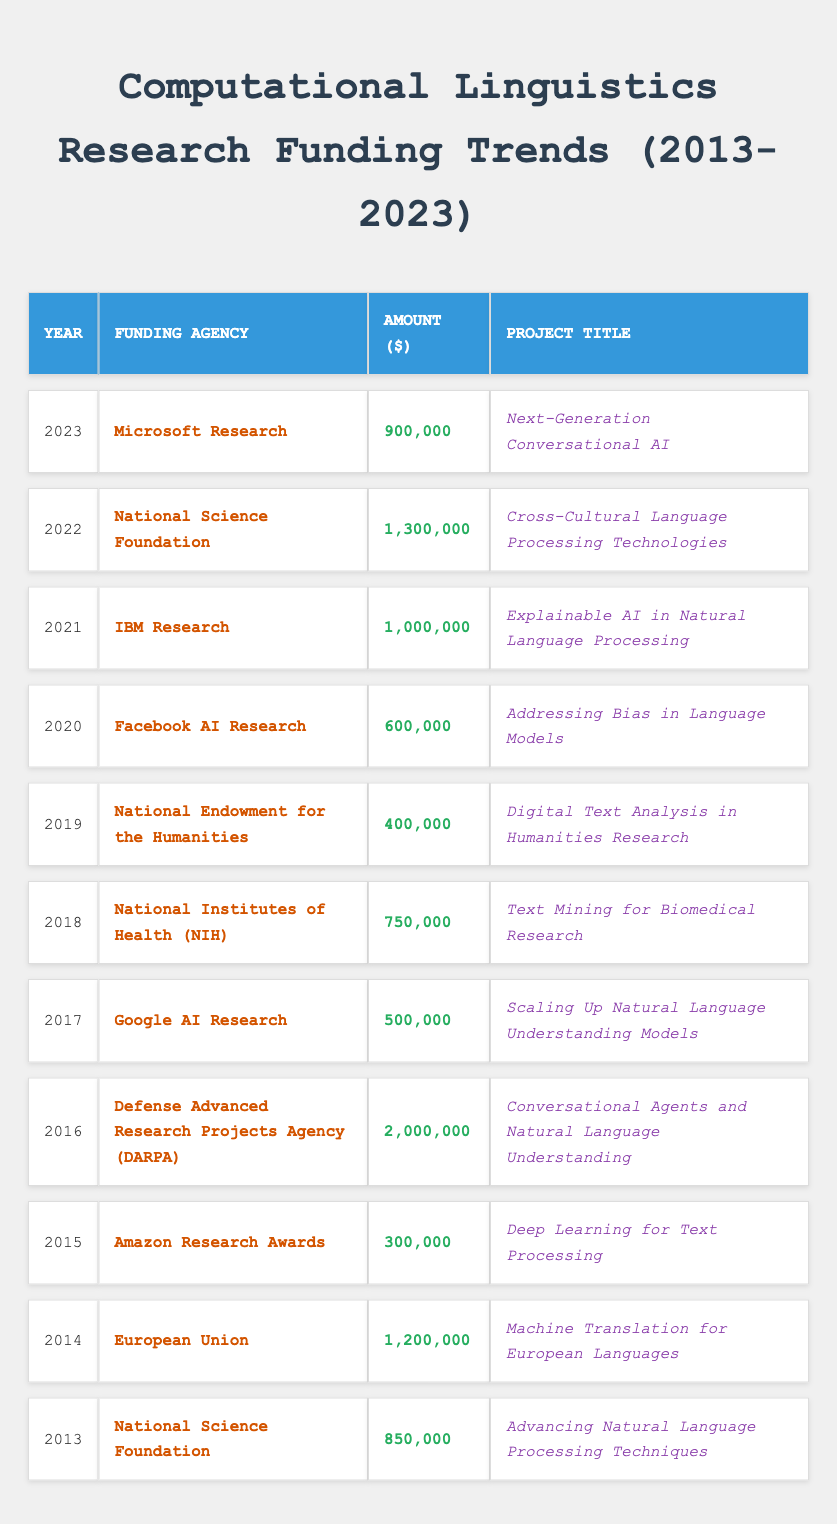What was the highest funding amount in a year? By reviewing the amounts funded each year, 2,000,000 from DARPA in 2016 is the highest.
Answer: 2,000,000 Which funding agency contributed the most funding in 2022? In 2022, the National Science Foundation provided the highest funding amount of 1,300,000.
Answer: National Science Foundation What is the total amount of funding received in 2019? In 2019, the funding amount is 400,000, which is the only data point for that year.
Answer: 400,000 What was the funding amount in 2015 compared to 2016? The funding in 2015 was 300,000, and in 2016, it was 2,000,000. The difference is 2,000,000 - 300,000 = 1,700,000.
Answer: 1,700,000 Was funding for AI research provided by Facebook in 2021? No, Facebook AI Research provided funding in 2020, not in 2021.
Answer: No What is the average funding amount over the 11 years? First, sum all funding amounts: 850,000 + 1,200,000 + 300,000 + 2,000,000 + 500,000 + 750,000 + 400,000 + 600,000 + 1,000,000 + 1,300,000 + 900,000 = 9,750,000. Then divide by 11 years: 9,750,000 / 11 = approximately 886,364.
Answer: 886,364 In which year did the National Science Foundation make its highest funding contribution? The National Science Foundation contributed 1,300,000 in 2022, which is the highest for them in the data.
Answer: 2022 Which year saw a decrease in funding compared to the previous year? Comparing the years shows that funding decreased from 2016 (2,000,000) to 2017 (500,000).
Answer: 2017 How many distinct funding agencies were involved over the decade? There are 10 distinct funding agencies listed: 1) NSF, 2) EU, 3) Amazon, 4) DARPA, 5) Google, 6) NIH, 7) NEH, 8) Facebook, 9) IBM, 10) Microsoft.
Answer: 10 What funding agency has consistent contributions every two years? The National Science Foundation appears in 2013, 2016, and 2022 indicating a consistent cycle of funding every two years.
Answer: National Science Foundation What was the funding trend from 2013 to 2023? The funding trend generally increased over the years, starting from 850,000 in 2013, seeing fluctuations, with a notable increase in 2021 (1,000,000) and peaked in 2022 (1,300,000).
Answer: Generally increasing 